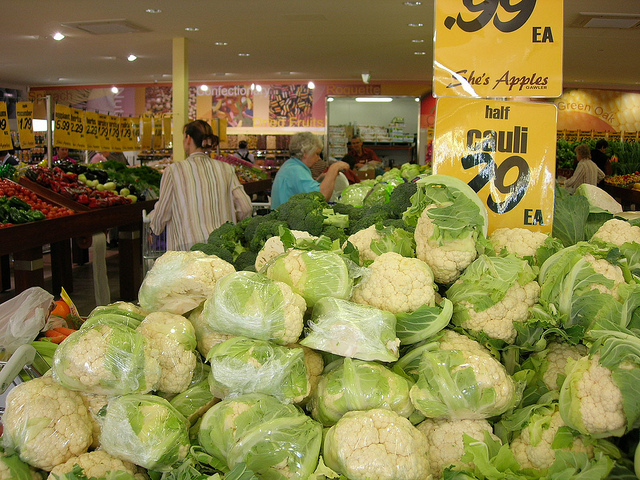How many people on any type of bike are facing the camera? Based on the visual information available in the image, there appear to be no people on any type of bike present, facing the camera or otherwise. 